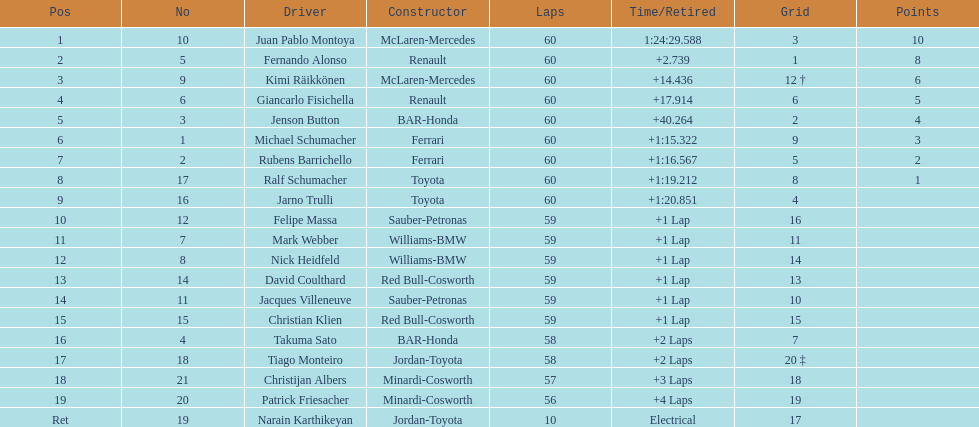What is the quantity of toyota's on the list? 4. 